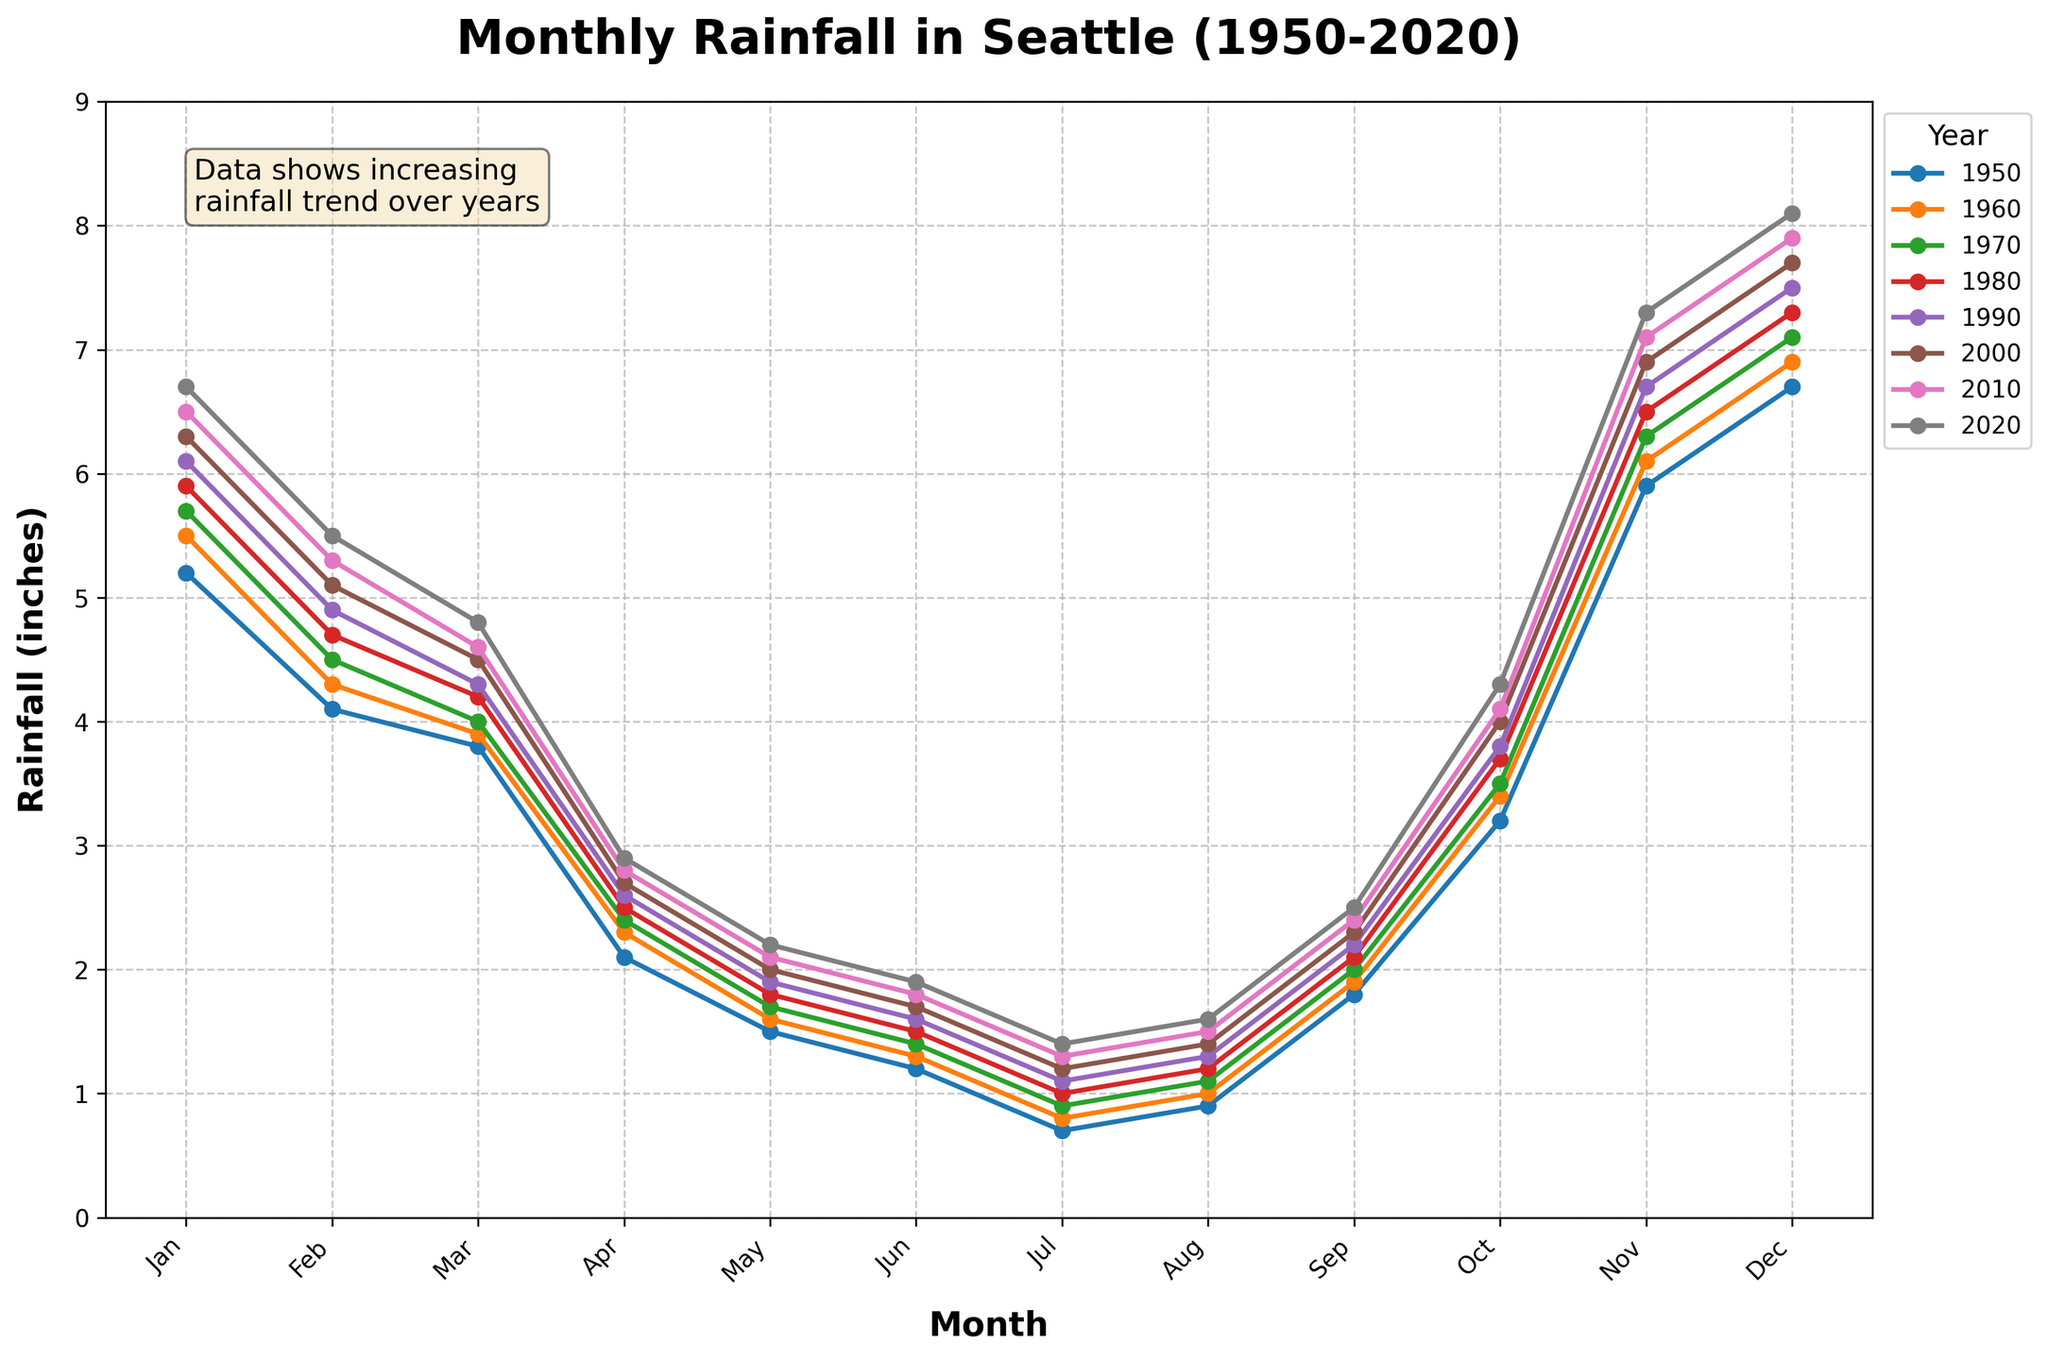What's the average rainfall for December in 1980 and 2020? Look at the heights of the lines representing the years 1980 and 2020 for December. In 1980, the rainfall is 7.3 inches, and in 2020, it is 8.1 inches. To find the average, add them (7.3 + 8.1 = 15.4) and divide by 2 (15.4/2 = 7.7).
Answer: 7.7 How has the annual rainfall for March changed from 1950 to 2020? In 1950, March's rainfall was 3.8 inches. By 2020, it increased to 4.8 inches. Subtract the 1950 value from the 2020 value (4.8 - 3.8), which gives a 1-inch increase.
Answer: 1 inch increase In September, which year had the lowest rainfall? Check the heights of the lines for September for each year. In 1950, the rainfall was 1.8 inches. For 1960, it was 1.9 inches. For 1970, it was 2.0 inches. For 1980, it was 2.1 inches. For 1990, it was 2.2 inches. For 2000, it was 2.3 inches. For 2010, it was 2.4 inches. Lastly, in 2020, it was 2.5 inches. The lowest value is 1.8 inches in 1950.
Answer: 1950 Which month generally experiences the highest levels of rainfall, according to the chart? Compare the peaks of the lines for each month across all years. November and December have lines that reach higher levels consistently. Among these, December seems to have the highest peaks over most years, with the highest value of 8.1 inches in 2020.
Answer: December What is the total rainfall for July and August combined in 2020? Look at the values for 2020 for July (1.4 inches) and August (1.6 inches), add these values together (1.4 + 1.6 = 3.0 inches).
Answer: 3.0 inches Is there a noticeable trend in annual rainfall from January over the years? Observe the line heights for January across the years 1950, 1960, 1970, 1980, 1990, 2000, 2010, and 2020. The rainfall in January increases gradually from 5.2 inches in 1950 to 6.7 inches in 2020. This indicates an increasing trend in the January rainfall over the years.
Answer: Increasing How does the rainfall in June of 1980 compare to that in June of 2000? Check the height of the lines for June in 1980 (1.5 inches) and 2000 (1.7 inches). The value in 2000 is higher than in 1980.
Answer: 2000 is higher Calculate the average monthly rainfall for 2010. Sum all monthly values for 2010: (6.5 + 5.3 + 4.6 + 2.8 + 2.1 + 1.8 + 1.3 + 1.5 + 2.4 + 4.1 + 7.1 + 7.9 = 47.4 inches). Divide by the number of months (12), so the average is 47.4/12 ≈ 3.95 inches.
Answer: 3.95 inches 